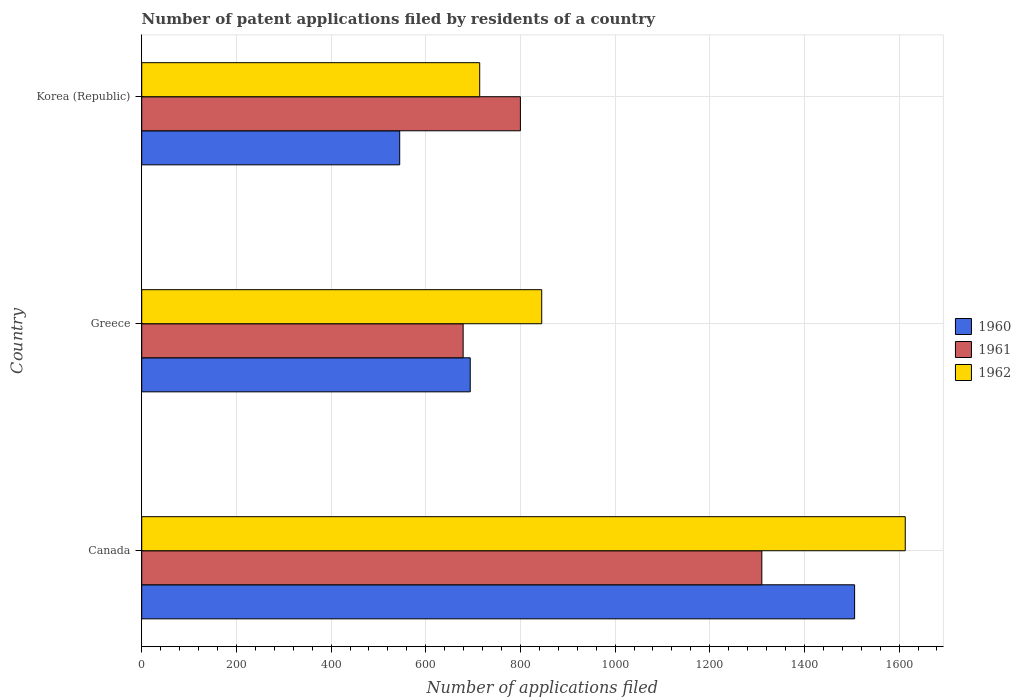How many different coloured bars are there?
Your response must be concise. 3. Are the number of bars per tick equal to the number of legend labels?
Provide a succinct answer. Yes. How many bars are there on the 1st tick from the top?
Ensure brevity in your answer.  3. What is the number of applications filed in 1962 in Canada?
Keep it short and to the point. 1613. Across all countries, what is the maximum number of applications filed in 1961?
Provide a succinct answer. 1310. Across all countries, what is the minimum number of applications filed in 1960?
Offer a very short reply. 545. What is the total number of applications filed in 1962 in the graph?
Offer a very short reply. 3172. What is the difference between the number of applications filed in 1962 in Canada and that in Greece?
Ensure brevity in your answer.  768. What is the average number of applications filed in 1960 per country?
Offer a very short reply. 915. What is the difference between the number of applications filed in 1962 and number of applications filed in 1961 in Greece?
Ensure brevity in your answer.  166. In how many countries, is the number of applications filed in 1962 greater than 1520 ?
Offer a terse response. 1. What is the ratio of the number of applications filed in 1960 in Canada to that in Korea (Republic)?
Make the answer very short. 2.76. Is the number of applications filed in 1962 in Greece less than that in Korea (Republic)?
Make the answer very short. No. What is the difference between the highest and the second highest number of applications filed in 1962?
Your response must be concise. 768. What is the difference between the highest and the lowest number of applications filed in 1962?
Your answer should be compact. 899. In how many countries, is the number of applications filed in 1960 greater than the average number of applications filed in 1960 taken over all countries?
Make the answer very short. 1. Is the sum of the number of applications filed in 1962 in Greece and Korea (Republic) greater than the maximum number of applications filed in 1960 across all countries?
Provide a short and direct response. Yes. How many bars are there?
Provide a succinct answer. 9. How many countries are there in the graph?
Your answer should be very brief. 3. What is the difference between two consecutive major ticks on the X-axis?
Give a very brief answer. 200. Are the values on the major ticks of X-axis written in scientific E-notation?
Ensure brevity in your answer.  No. Where does the legend appear in the graph?
Your answer should be compact. Center right. How many legend labels are there?
Provide a succinct answer. 3. What is the title of the graph?
Your answer should be very brief. Number of patent applications filed by residents of a country. Does "2010" appear as one of the legend labels in the graph?
Offer a very short reply. No. What is the label or title of the X-axis?
Keep it short and to the point. Number of applications filed. What is the Number of applications filed of 1960 in Canada?
Ensure brevity in your answer.  1506. What is the Number of applications filed in 1961 in Canada?
Offer a terse response. 1310. What is the Number of applications filed in 1962 in Canada?
Your answer should be compact. 1613. What is the Number of applications filed of 1960 in Greece?
Your answer should be compact. 694. What is the Number of applications filed in 1961 in Greece?
Give a very brief answer. 679. What is the Number of applications filed of 1962 in Greece?
Offer a terse response. 845. What is the Number of applications filed in 1960 in Korea (Republic)?
Your answer should be compact. 545. What is the Number of applications filed of 1961 in Korea (Republic)?
Ensure brevity in your answer.  800. What is the Number of applications filed in 1962 in Korea (Republic)?
Your answer should be compact. 714. Across all countries, what is the maximum Number of applications filed of 1960?
Make the answer very short. 1506. Across all countries, what is the maximum Number of applications filed in 1961?
Provide a succinct answer. 1310. Across all countries, what is the maximum Number of applications filed in 1962?
Your response must be concise. 1613. Across all countries, what is the minimum Number of applications filed in 1960?
Ensure brevity in your answer.  545. Across all countries, what is the minimum Number of applications filed in 1961?
Offer a very short reply. 679. Across all countries, what is the minimum Number of applications filed of 1962?
Your answer should be very brief. 714. What is the total Number of applications filed in 1960 in the graph?
Your response must be concise. 2745. What is the total Number of applications filed of 1961 in the graph?
Offer a very short reply. 2789. What is the total Number of applications filed in 1962 in the graph?
Your answer should be compact. 3172. What is the difference between the Number of applications filed in 1960 in Canada and that in Greece?
Your response must be concise. 812. What is the difference between the Number of applications filed in 1961 in Canada and that in Greece?
Offer a very short reply. 631. What is the difference between the Number of applications filed of 1962 in Canada and that in Greece?
Offer a terse response. 768. What is the difference between the Number of applications filed in 1960 in Canada and that in Korea (Republic)?
Offer a terse response. 961. What is the difference between the Number of applications filed of 1961 in Canada and that in Korea (Republic)?
Provide a short and direct response. 510. What is the difference between the Number of applications filed in 1962 in Canada and that in Korea (Republic)?
Offer a very short reply. 899. What is the difference between the Number of applications filed in 1960 in Greece and that in Korea (Republic)?
Make the answer very short. 149. What is the difference between the Number of applications filed in 1961 in Greece and that in Korea (Republic)?
Ensure brevity in your answer.  -121. What is the difference between the Number of applications filed of 1962 in Greece and that in Korea (Republic)?
Your response must be concise. 131. What is the difference between the Number of applications filed in 1960 in Canada and the Number of applications filed in 1961 in Greece?
Offer a terse response. 827. What is the difference between the Number of applications filed of 1960 in Canada and the Number of applications filed of 1962 in Greece?
Make the answer very short. 661. What is the difference between the Number of applications filed in 1961 in Canada and the Number of applications filed in 1962 in Greece?
Offer a very short reply. 465. What is the difference between the Number of applications filed of 1960 in Canada and the Number of applications filed of 1961 in Korea (Republic)?
Provide a succinct answer. 706. What is the difference between the Number of applications filed in 1960 in Canada and the Number of applications filed in 1962 in Korea (Republic)?
Make the answer very short. 792. What is the difference between the Number of applications filed of 1961 in Canada and the Number of applications filed of 1962 in Korea (Republic)?
Offer a very short reply. 596. What is the difference between the Number of applications filed in 1960 in Greece and the Number of applications filed in 1961 in Korea (Republic)?
Make the answer very short. -106. What is the difference between the Number of applications filed in 1960 in Greece and the Number of applications filed in 1962 in Korea (Republic)?
Ensure brevity in your answer.  -20. What is the difference between the Number of applications filed of 1961 in Greece and the Number of applications filed of 1962 in Korea (Republic)?
Your response must be concise. -35. What is the average Number of applications filed of 1960 per country?
Provide a short and direct response. 915. What is the average Number of applications filed of 1961 per country?
Your answer should be compact. 929.67. What is the average Number of applications filed in 1962 per country?
Provide a succinct answer. 1057.33. What is the difference between the Number of applications filed in 1960 and Number of applications filed in 1961 in Canada?
Your response must be concise. 196. What is the difference between the Number of applications filed in 1960 and Number of applications filed in 1962 in Canada?
Make the answer very short. -107. What is the difference between the Number of applications filed of 1961 and Number of applications filed of 1962 in Canada?
Give a very brief answer. -303. What is the difference between the Number of applications filed of 1960 and Number of applications filed of 1961 in Greece?
Make the answer very short. 15. What is the difference between the Number of applications filed in 1960 and Number of applications filed in 1962 in Greece?
Your answer should be very brief. -151. What is the difference between the Number of applications filed of 1961 and Number of applications filed of 1962 in Greece?
Your response must be concise. -166. What is the difference between the Number of applications filed of 1960 and Number of applications filed of 1961 in Korea (Republic)?
Your response must be concise. -255. What is the difference between the Number of applications filed of 1960 and Number of applications filed of 1962 in Korea (Republic)?
Provide a short and direct response. -169. What is the difference between the Number of applications filed in 1961 and Number of applications filed in 1962 in Korea (Republic)?
Offer a very short reply. 86. What is the ratio of the Number of applications filed in 1960 in Canada to that in Greece?
Make the answer very short. 2.17. What is the ratio of the Number of applications filed of 1961 in Canada to that in Greece?
Offer a terse response. 1.93. What is the ratio of the Number of applications filed in 1962 in Canada to that in Greece?
Provide a short and direct response. 1.91. What is the ratio of the Number of applications filed in 1960 in Canada to that in Korea (Republic)?
Your response must be concise. 2.76. What is the ratio of the Number of applications filed in 1961 in Canada to that in Korea (Republic)?
Keep it short and to the point. 1.64. What is the ratio of the Number of applications filed of 1962 in Canada to that in Korea (Republic)?
Offer a very short reply. 2.26. What is the ratio of the Number of applications filed of 1960 in Greece to that in Korea (Republic)?
Your answer should be compact. 1.27. What is the ratio of the Number of applications filed in 1961 in Greece to that in Korea (Republic)?
Make the answer very short. 0.85. What is the ratio of the Number of applications filed of 1962 in Greece to that in Korea (Republic)?
Give a very brief answer. 1.18. What is the difference between the highest and the second highest Number of applications filed in 1960?
Your answer should be very brief. 812. What is the difference between the highest and the second highest Number of applications filed of 1961?
Keep it short and to the point. 510. What is the difference between the highest and the second highest Number of applications filed of 1962?
Offer a terse response. 768. What is the difference between the highest and the lowest Number of applications filed of 1960?
Your answer should be compact. 961. What is the difference between the highest and the lowest Number of applications filed in 1961?
Provide a short and direct response. 631. What is the difference between the highest and the lowest Number of applications filed of 1962?
Make the answer very short. 899. 